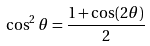<formula> <loc_0><loc_0><loc_500><loc_500>\cos ^ { 2 } \theta = { \frac { 1 + \cos ( 2 \theta ) } { 2 } }</formula> 